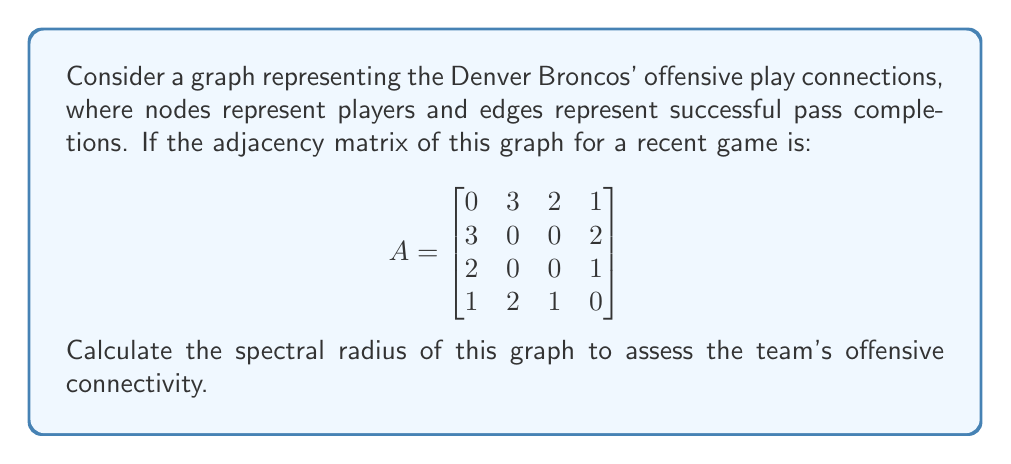Provide a solution to this math problem. To find the spectral radius of the graph, we need to follow these steps:

1) The spectral radius is the largest absolute eigenvalue of the adjacency matrix.

2) To find the eigenvalues, we need to solve the characteristic equation:
   $$\det(A - \lambda I) = 0$$

3) Expanding this determinant:
   $$\begin{vmatrix}
   -\lambda & 3 & 2 & 1 \\
   3 & -\lambda & 0 & 2 \\
   2 & 0 & -\lambda & 1 \\
   1 & 2 & 1 & -\lambda
   \end{vmatrix} = 0$$

4) This expands to the characteristic polynomial:
   $$\lambda^4 - 18\lambda^2 - 16\lambda + 9 = 0$$

5) This fourth-degree polynomial doesn't have a simple factorization, so we need to use numerical methods to find its roots.

6) Using a computer algebra system or numerical solver, we find the roots are approximately:
   $\lambda_1 \approx 4.2915$
   $\lambda_2 \approx -3.1623$
   $\lambda_3 \approx 1.4354$
   $\lambda_4 \approx -0.5646$

7) The spectral radius is the largest absolute value among these eigenvalues, which is $|\lambda_1| \approx 4.2915$.

This value indicates the overall connectivity and "strength" of the passing network in the game.
Answer: $4.2915$ 